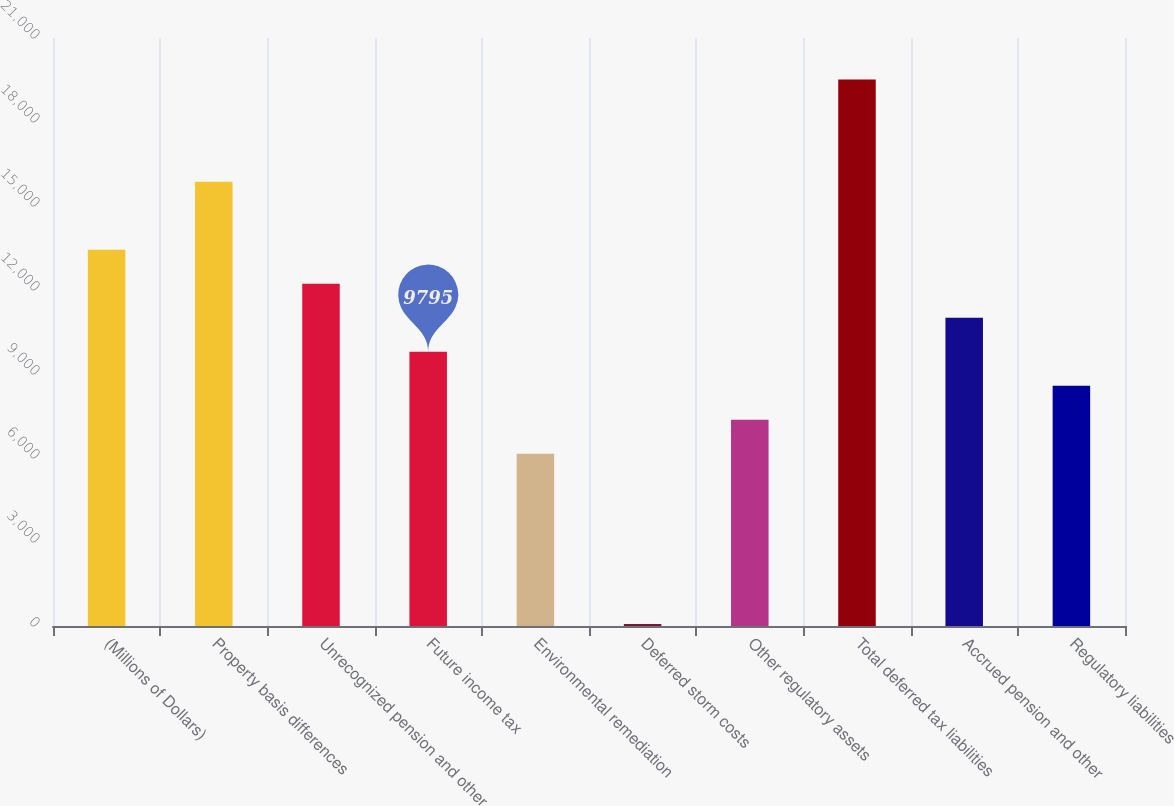<chart> <loc_0><loc_0><loc_500><loc_500><bar_chart><fcel>(Millions of Dollars)<fcel>Property basis differences<fcel>Unrecognized pension and other<fcel>Future income tax<fcel>Environmental remediation<fcel>Deferred storm costs<fcel>Other regulatory assets<fcel>Total deferred tax liabilities<fcel>Accrued pension and other<fcel>Regulatory liabilities<nl><fcel>13440<fcel>15870<fcel>12225<fcel>9795<fcel>6150<fcel>75<fcel>7365<fcel>19515<fcel>11010<fcel>8580<nl></chart> 